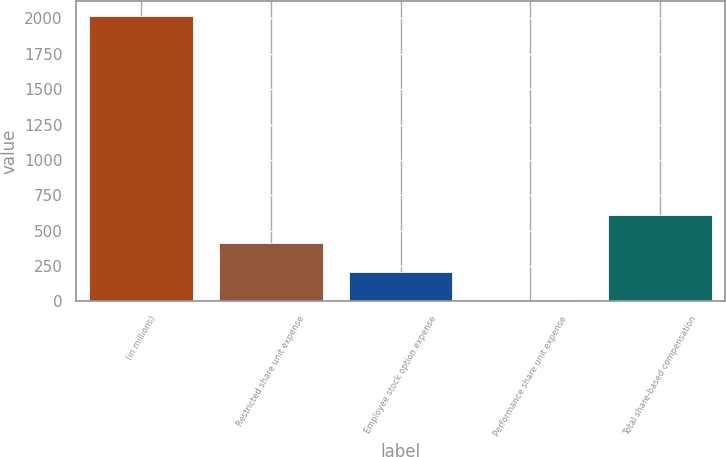Convert chart. <chart><loc_0><loc_0><loc_500><loc_500><bar_chart><fcel>(in millions)<fcel>Restricted share unit expense<fcel>Employee stock option expense<fcel>Performance share unit expense<fcel>Total share-based compensation<nl><fcel>2019<fcel>411<fcel>210<fcel>9<fcel>612<nl></chart> 